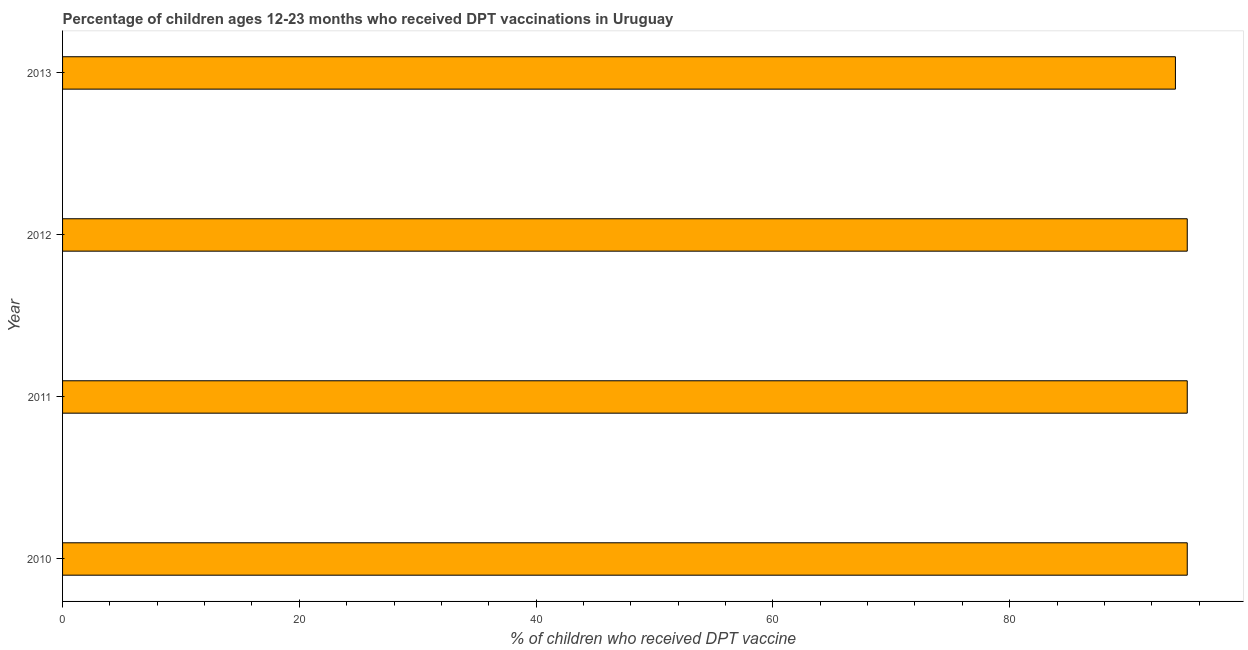What is the title of the graph?
Provide a short and direct response. Percentage of children ages 12-23 months who received DPT vaccinations in Uruguay. What is the label or title of the X-axis?
Ensure brevity in your answer.  % of children who received DPT vaccine. What is the label or title of the Y-axis?
Your response must be concise. Year. What is the percentage of children who received dpt vaccine in 2011?
Your answer should be compact. 95. Across all years, what is the minimum percentage of children who received dpt vaccine?
Your answer should be compact. 94. In which year was the percentage of children who received dpt vaccine minimum?
Your response must be concise. 2013. What is the sum of the percentage of children who received dpt vaccine?
Provide a succinct answer. 379. What is the average percentage of children who received dpt vaccine per year?
Ensure brevity in your answer.  94. In how many years, is the percentage of children who received dpt vaccine greater than 52 %?
Make the answer very short. 4. Do a majority of the years between 2013 and 2012 (inclusive) have percentage of children who received dpt vaccine greater than 80 %?
Give a very brief answer. No. What is the ratio of the percentage of children who received dpt vaccine in 2010 to that in 2013?
Your answer should be very brief. 1.01. What is the difference between the highest and the second highest percentage of children who received dpt vaccine?
Offer a very short reply. 0. In how many years, is the percentage of children who received dpt vaccine greater than the average percentage of children who received dpt vaccine taken over all years?
Keep it short and to the point. 3. How many bars are there?
Your answer should be compact. 4. What is the % of children who received DPT vaccine in 2010?
Provide a short and direct response. 95. What is the % of children who received DPT vaccine of 2013?
Ensure brevity in your answer.  94. What is the difference between the % of children who received DPT vaccine in 2010 and 2011?
Provide a short and direct response. 0. What is the difference between the % of children who received DPT vaccine in 2010 and 2012?
Offer a very short reply. 0. What is the difference between the % of children who received DPT vaccine in 2010 and 2013?
Offer a terse response. 1. What is the difference between the % of children who received DPT vaccine in 2011 and 2012?
Your answer should be compact. 0. What is the difference between the % of children who received DPT vaccine in 2011 and 2013?
Offer a terse response. 1. What is the difference between the % of children who received DPT vaccine in 2012 and 2013?
Provide a short and direct response. 1. What is the ratio of the % of children who received DPT vaccine in 2010 to that in 2011?
Ensure brevity in your answer.  1. What is the ratio of the % of children who received DPT vaccine in 2010 to that in 2012?
Provide a short and direct response. 1. What is the ratio of the % of children who received DPT vaccine in 2011 to that in 2012?
Ensure brevity in your answer.  1. What is the ratio of the % of children who received DPT vaccine in 2012 to that in 2013?
Make the answer very short. 1.01. 